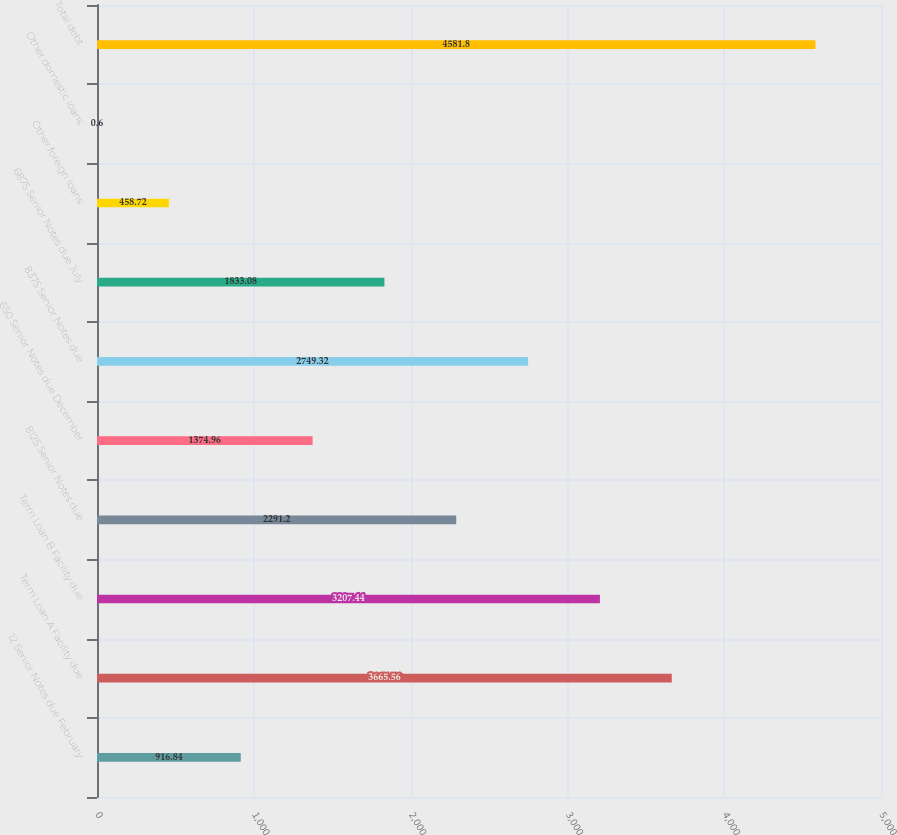Convert chart. <chart><loc_0><loc_0><loc_500><loc_500><bar_chart><fcel>12 Senior Notes due February<fcel>Term Loan A Facility due<fcel>Term Loan B Facility due<fcel>8125 Senior Notes due<fcel>650 Senior Notes due December<fcel>8375 Senior Notes due<fcel>6875 Senior Notes due July<fcel>Other foreign loans<fcel>Other domestic loans<fcel>Total debt<nl><fcel>916.84<fcel>3665.56<fcel>3207.44<fcel>2291.2<fcel>1374.96<fcel>2749.32<fcel>1833.08<fcel>458.72<fcel>0.6<fcel>4581.8<nl></chart> 